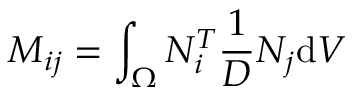Convert formula to latex. <formula><loc_0><loc_0><loc_500><loc_500>M _ { i j } = \int _ { \Omega } { N _ { i } ^ { T } \frac { 1 } { D } { N _ { j } } d V }</formula> 